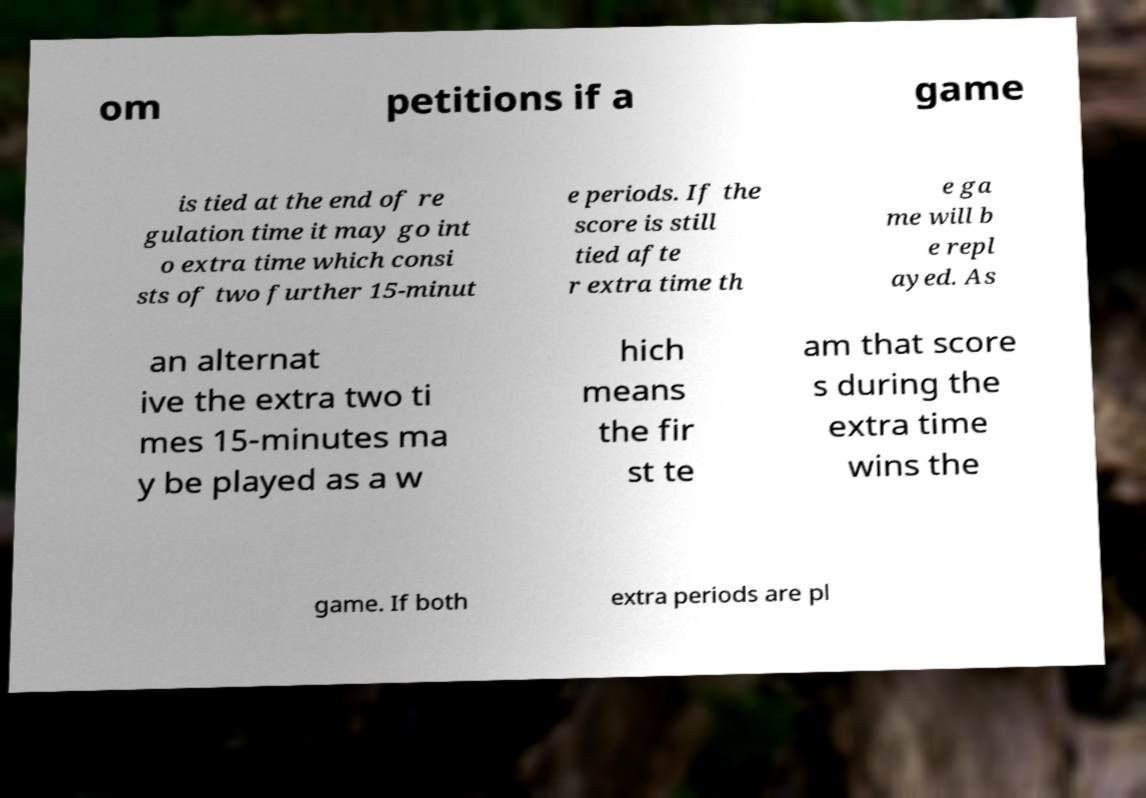Please identify and transcribe the text found in this image. om petitions if a game is tied at the end of re gulation time it may go int o extra time which consi sts of two further 15-minut e periods. If the score is still tied afte r extra time th e ga me will b e repl ayed. As an alternat ive the extra two ti mes 15-minutes ma y be played as a w hich means the fir st te am that score s during the extra time wins the game. If both extra periods are pl 